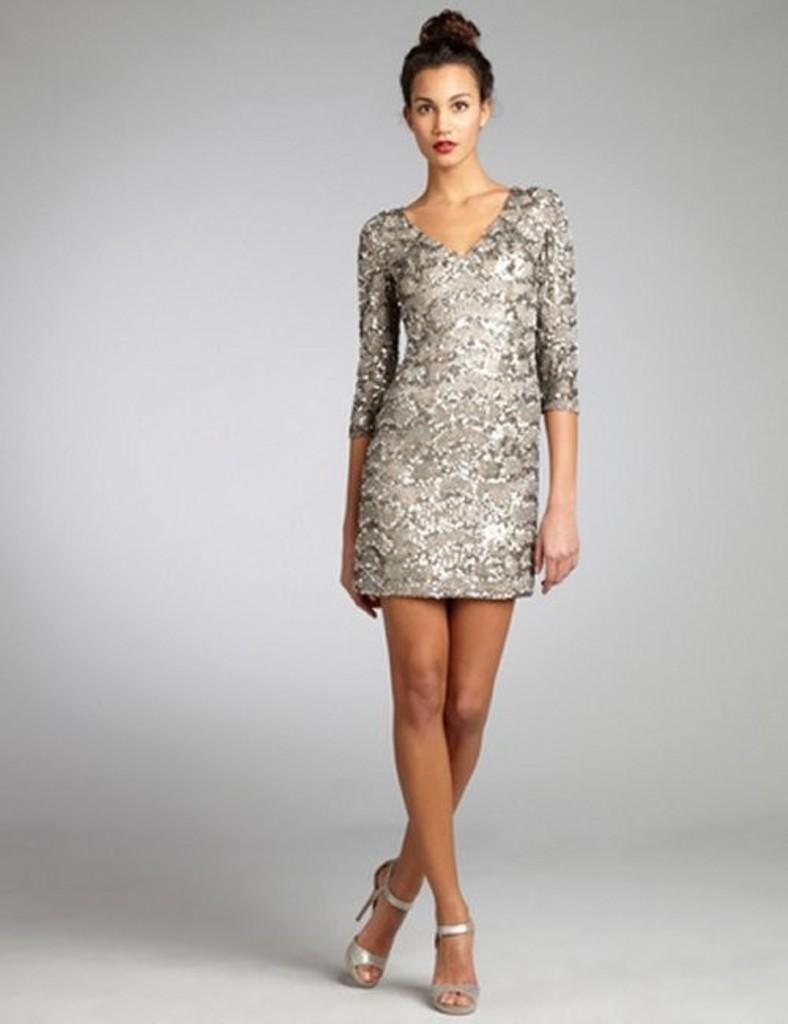Who is present in the image? There is a woman in the image. What is the woman doing in the image? The woman is standing on the floor. How does the woman react to the sudden jar in the image? There is no jar present in the image, so the woman's reaction cannot be determined. 